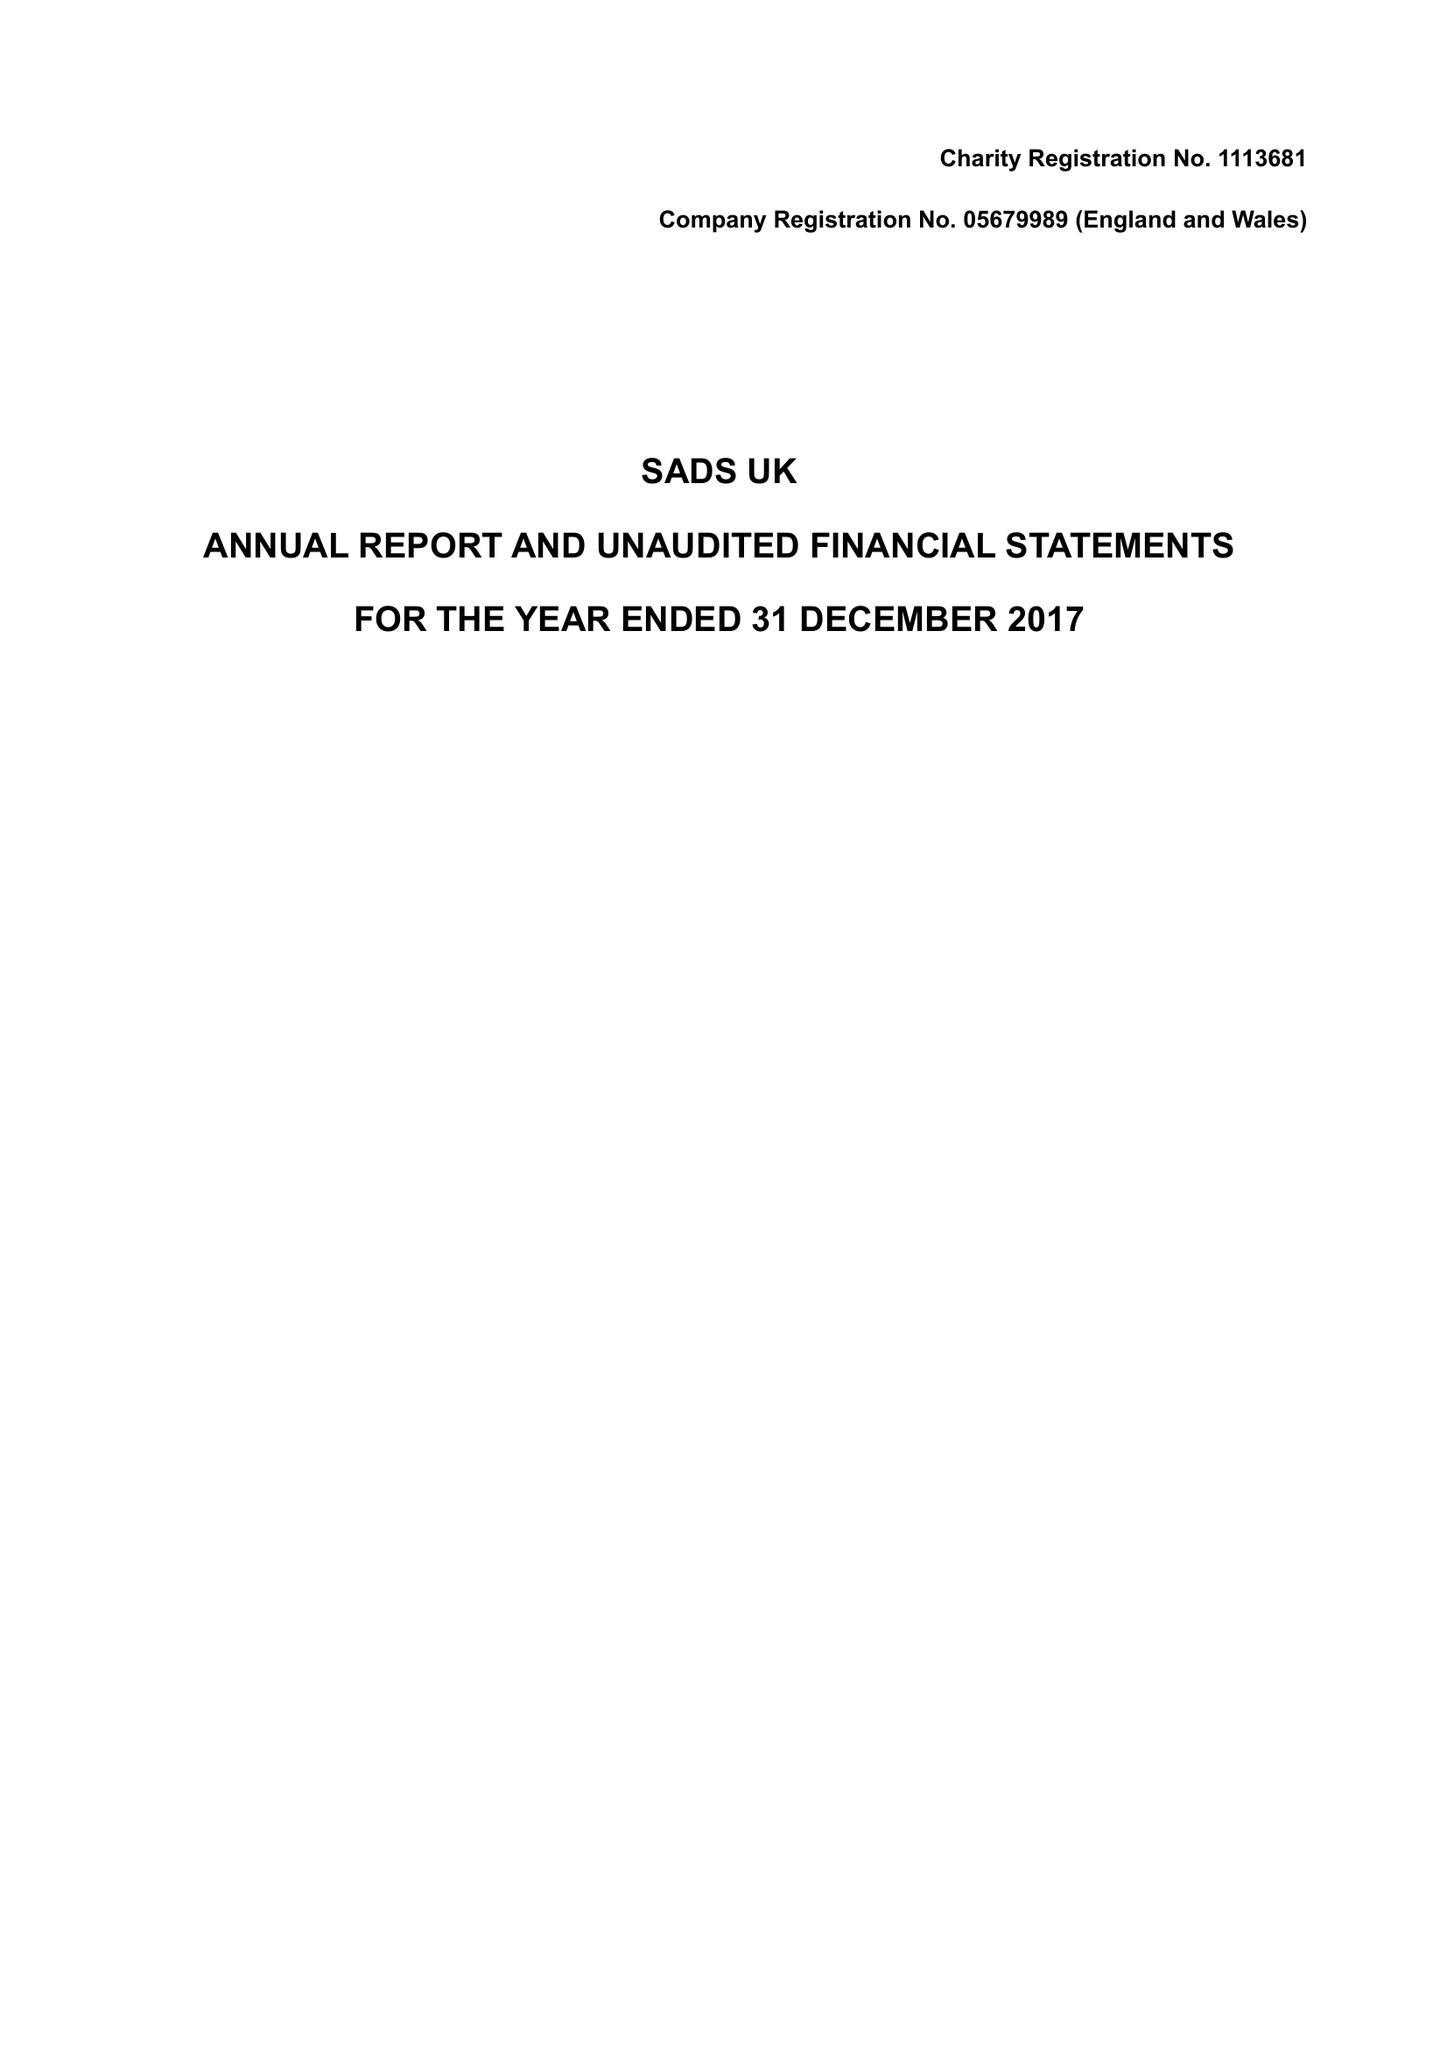What is the value for the charity_number?
Answer the question using a single word or phrase. 1113681 